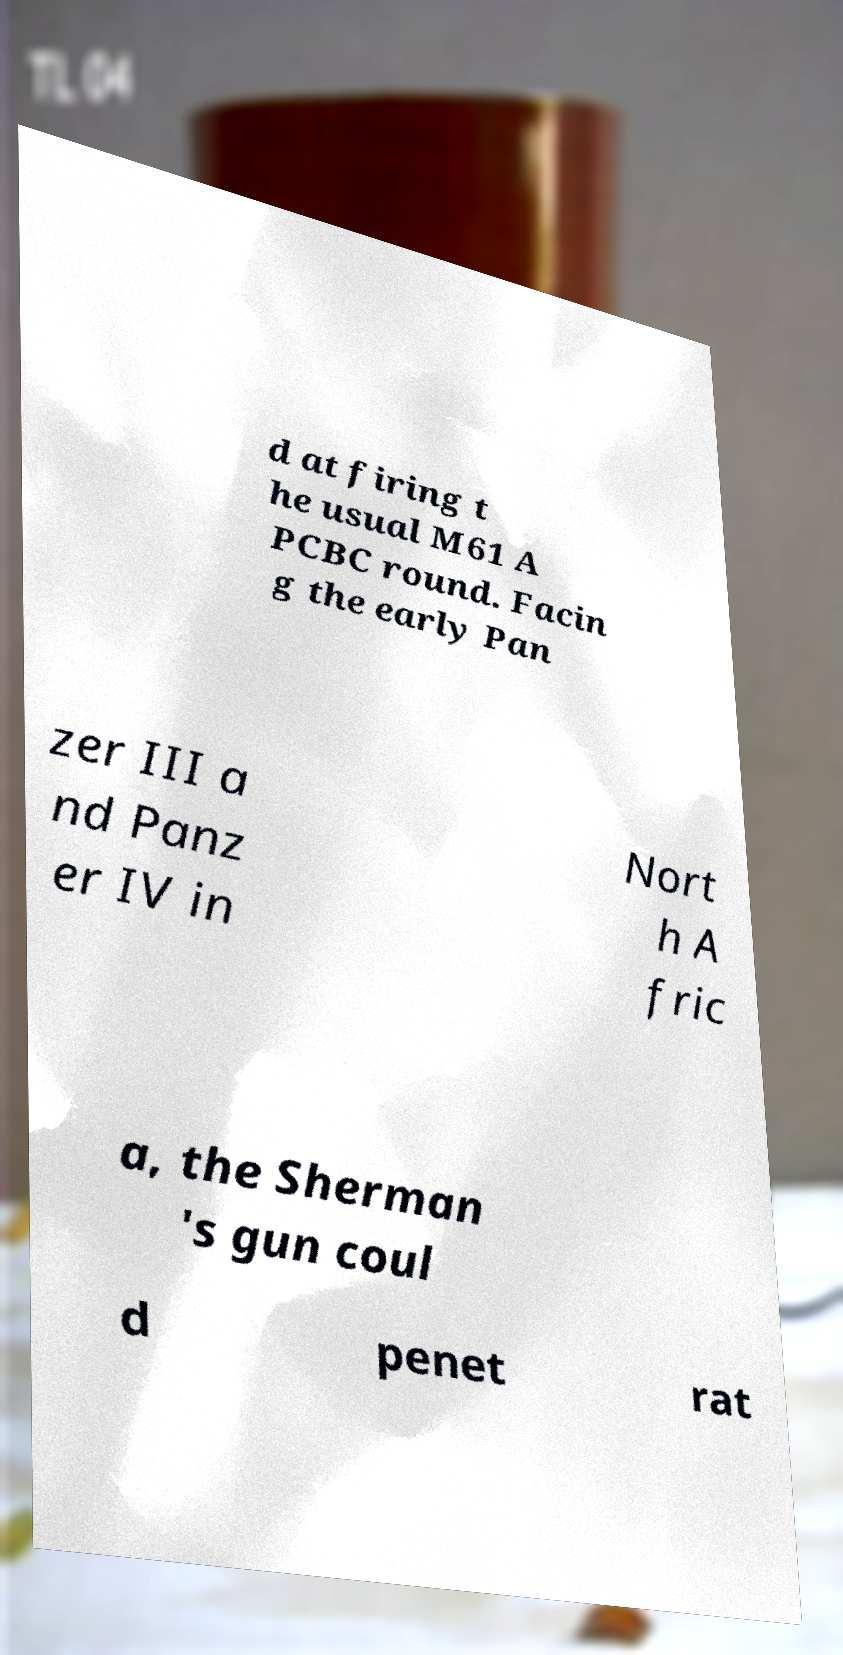I need the written content from this picture converted into text. Can you do that? d at firing t he usual M61 A PCBC round. Facin g the early Pan zer III a nd Panz er IV in Nort h A fric a, the Sherman 's gun coul d penet rat 